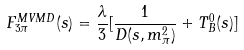Convert formula to latex. <formula><loc_0><loc_0><loc_500><loc_500>F _ { 3 \pi } ^ { M V M D } ( s ) = \frac { \lambda } { 3 } [ \frac { 1 } { D ( s , m _ { \pi } ^ { 2 } ) } + T _ { B } ^ { 0 } ( s ) ]</formula> 